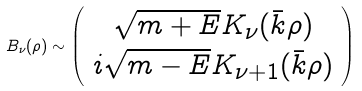Convert formula to latex. <formula><loc_0><loc_0><loc_500><loc_500>B _ { \nu } ( \rho ) \sim \left ( \begin{array} { c } \sqrt { m + E } K _ { \nu } ( \bar { k } \rho ) \\ i \sqrt { m - E } K _ { \nu + 1 } ( \bar { k } \rho ) \end{array} \right )</formula> 